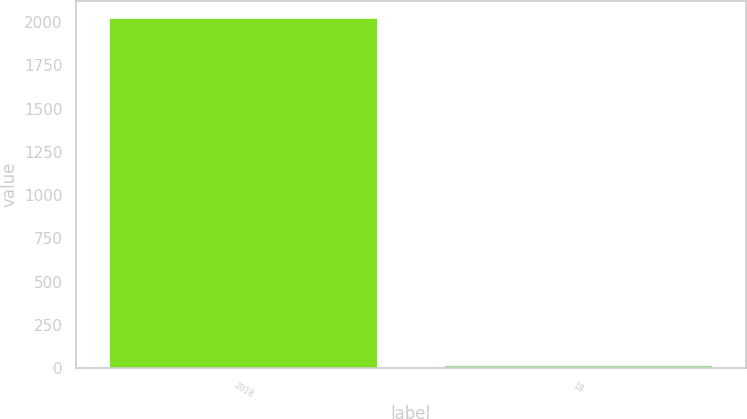Convert chart. <chart><loc_0><loc_0><loc_500><loc_500><bar_chart><fcel>2018<fcel>18<nl><fcel>2022<fcel>17<nl></chart> 